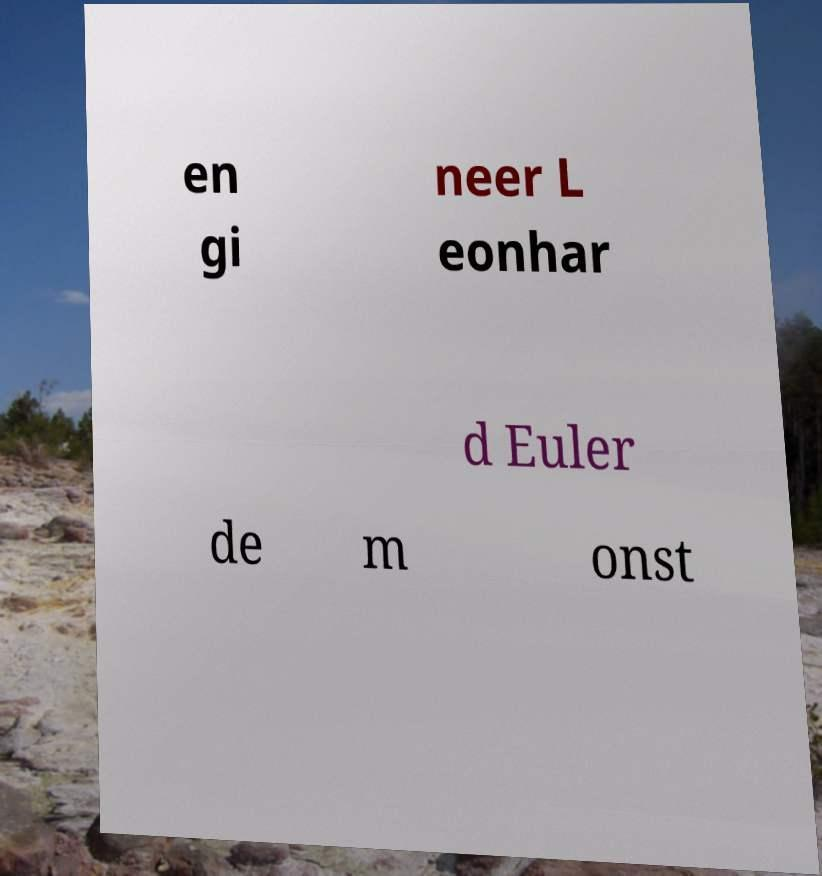I need the written content from this picture converted into text. Can you do that? en gi neer L eonhar d Euler de m onst 